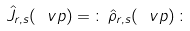<formula> <loc_0><loc_0><loc_500><loc_500>\hat { J } _ { r , s } ( \ v p ) = \, \colon \, \hat { \rho } _ { r , s } ( \ v p ) \, \colon</formula> 